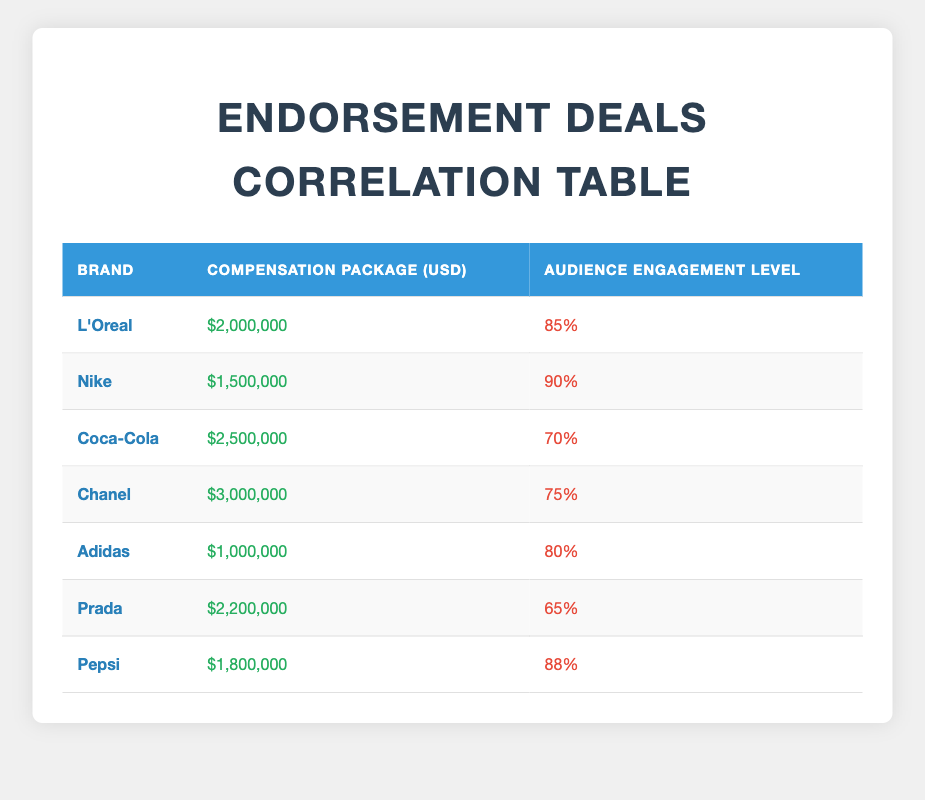What is the highest compensation package listed in the table? The highest compensation package is associated with the brand Chanel, which is $3,000,000. This can be easily identified by looking at the "Compensation Package (USD)" column and finding the maximum value.
Answer: 3,000,000 Which brand has the lowest audience engagement level? The brand with the lowest audience engagement level is Prada, with an engagement level of 65%. This value can be determined by examining the "Audience Engagement Level" column for the minimum value.
Answer: 65% Is there a brand that has a compensation package greater than $2,000,000 with a lower audience engagement level than 75%? Yes, Coca-Cola has a compensation package of $2,500,000 and an audience engagement level of 70%, which meets the criteria of having a higher compensation with lower engagement. This requires checking both the "Compensation Package (USD)" and "Audience Engagement Level" columns for such brands.
Answer: Yes What is the average audience engagement level of all the brands listed? To find the average audience engagement level, we first sum all engagement levels: (85 + 90 + 70 + 75 + 80 + 65 + 88) = 553. There are 7 brands in total, so we divide 553 by 7, resulting in an average engagement level of approximately 79%. This involves summing all values from the "Audience Engagement Level" column and then dividing by the count of brands.
Answer: 79 Which brand has the highest audience engagement level, and what is that level? The brand with the highest audience engagement level is Nike, with a level of 90%. This can be determined by identifying the maximum value in the "Audience Engagement Level" column and noting the corresponding brand.
Answer: 90 